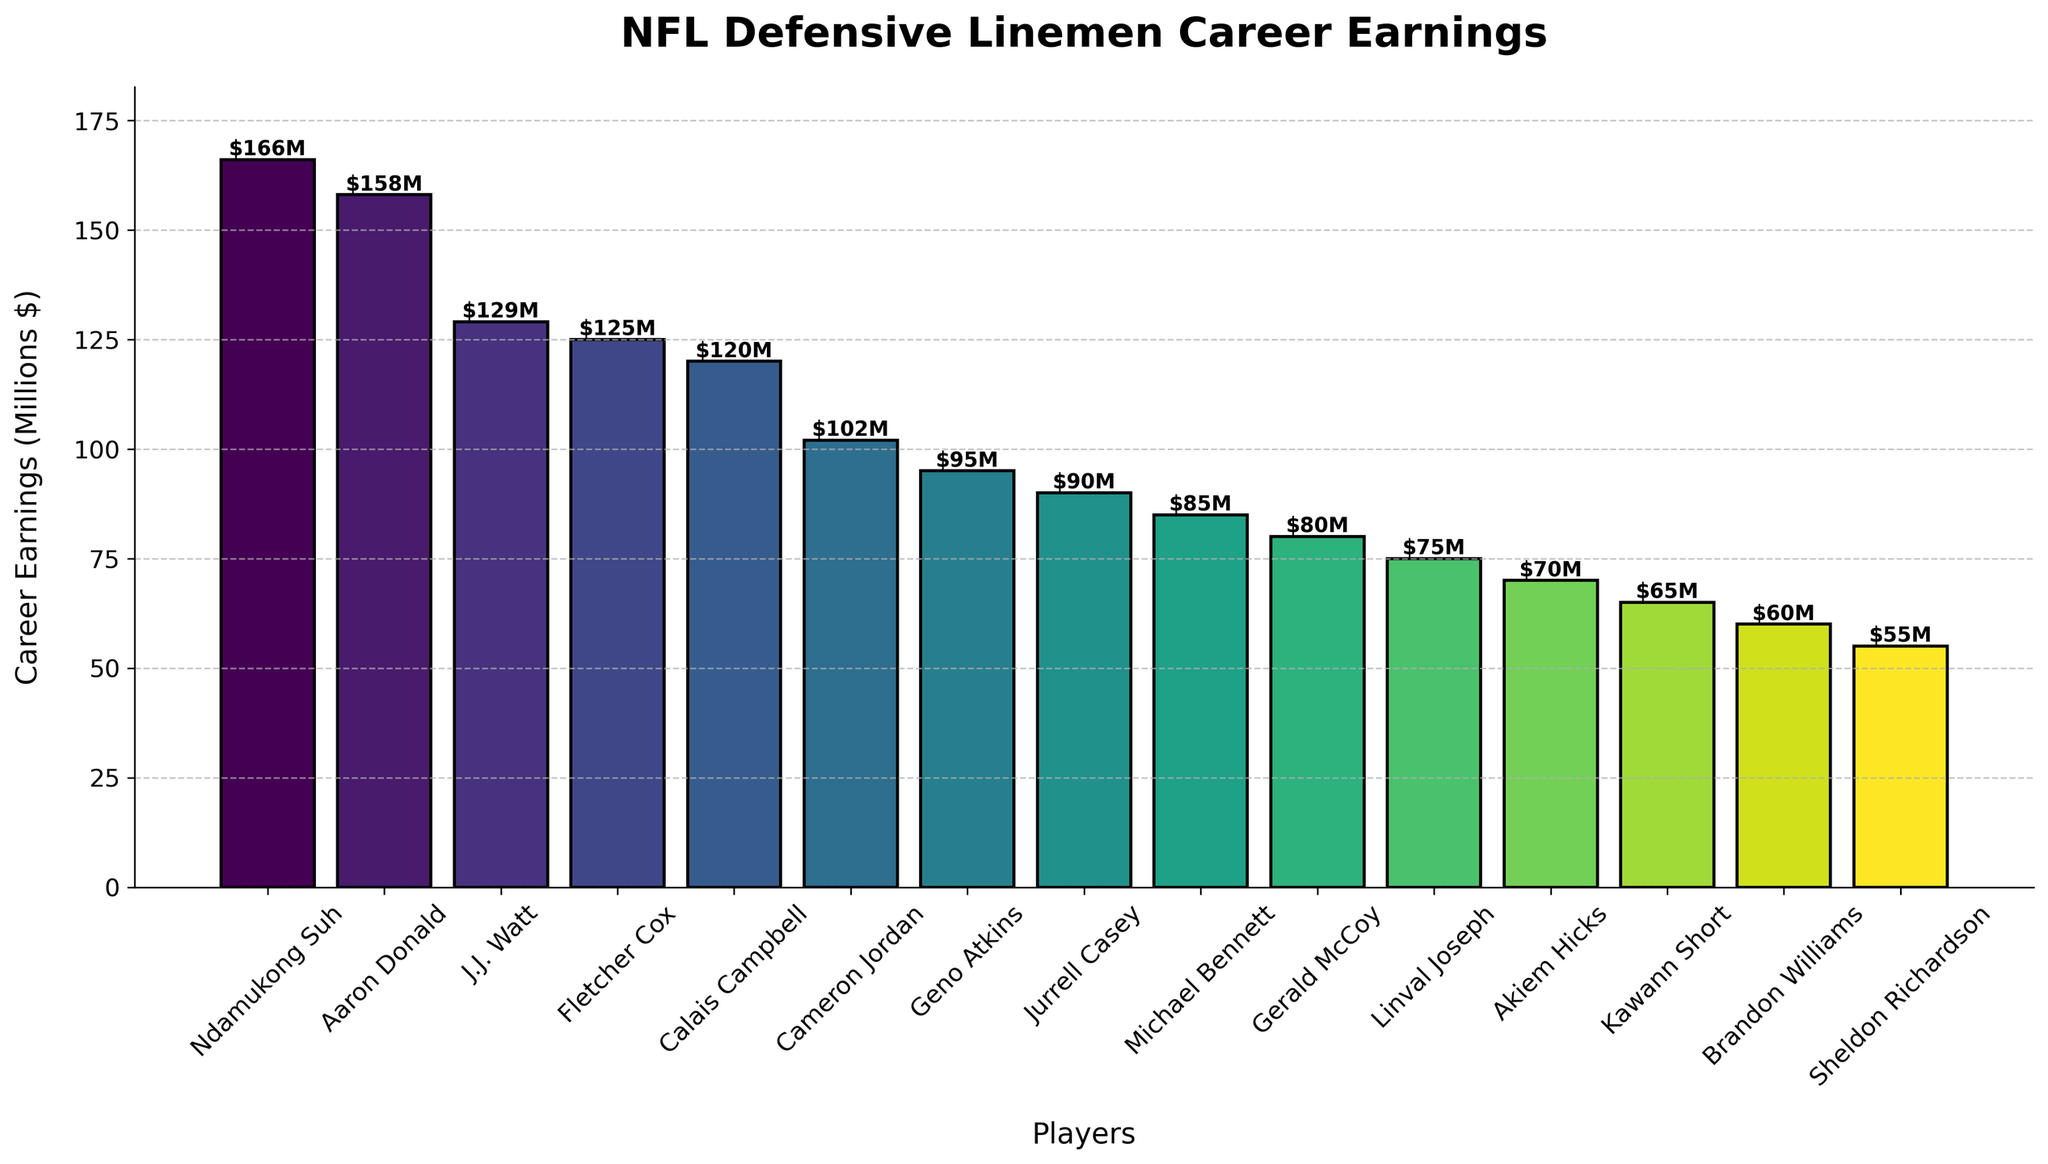What's the rank of Ndamukong Suh in terms of career earnings among the defensive linemen? From the figure, we can see that Ndamukong Suh's bar is the highest, indicating he has the highest career earnings among the defensive linemen listed.
Answer: 1st How much more has Ndamukong Suh earned in his career compared to Aaron Donald? Ndamukong Suh has career earnings of $166 million, while Aaron Donald has $158 million. The difference is $166M - $158M.
Answer: $8M Who are the top three defensive linemen in terms of career earnings? Observing the heights of the bars in descending order, the top three defensive linemen are Ndamukong Suh, Aaron Donald, and J.J. Watt.
Answer: Ndamukong Suh, Aaron Donald, J.J. Watt What's the combined career earnings of Calais Campbell and Cameron Jordan? Calais Campbell has $120 million and Cameron Jordan has $102 million in career earnings. Adding them together gives $120M + $102M.
Answer: $222M Which player has lower career earnings, Geno Atkins or Gerald McCoy? Comparing the heights of the bars for Geno Atkins (95 million) and Gerald McCoy (80 million), Gerald McCoy has lower career earnings.
Answer: Gerald McCoy What is the difference in career earnings between the player with the most earnings and the player with the least? Ndamukong Suh has the highest earning at $166 million and Sheldon Richardson has the lowest at $55 million. The difference is $166M - $55M.
Answer: $111M What's the sum of the career earnings of Fletcher Cox, Michael Bennett, and Linval Joseph? Adding the earnings: $125 million (Fletcher Cox) + $85 million (Michael Bennett) + $75 million (Linval Joseph) gives us a total.
Answer: $285M How does the height of Aaron Donald’s bar compare visually to that of J.J. Watt? Aaron Donald's bar is slightly taller than J.J. Watt’s bar, indicating higher career earnings.
Answer: Taller What's the average career earnings of the defensive linemen listed? Summing all the career earnings of the listed players and dividing by the number of players (15) will give the average:
($166M + $158M + $129M + $125M + $120M + $102M + $95M + $90M + $85M + $80M + $75M + $70M + $65M + $60M + $55M) / 15
Answer: $98.33M Which players have career earnings over $100 million? From the bars that extend above the $100 million mark, we can see the players are Ndamukong Suh, Aaron Donald, J.J. Watt, Fletcher Cox, Calais Campbell, and Cameron Jordan.
Answer: Ndamukong Suh, Aaron Donald, J.J. Watt, Fletcher Cox, Calais Campbell, Cameron Jordan 